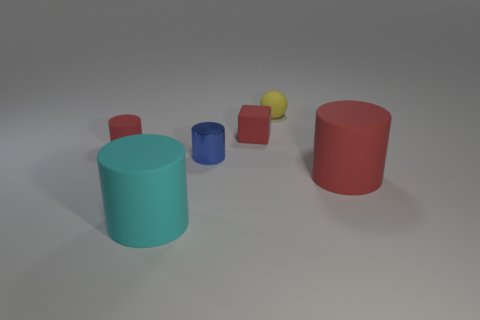Is there anything else that has the same material as the small blue cylinder?
Your answer should be compact. No. What shape is the tiny rubber object that is the same color as the small rubber cube?
Ensure brevity in your answer.  Cylinder. There is a red matte thing to the left of the large cylinder that is left of the large red rubber thing; how many big cyan rubber cylinders are behind it?
Give a very brief answer. 0. What color is the sphere that is the same size as the metallic thing?
Your answer should be compact. Yellow. There is a red object in front of the red matte cylinder that is to the left of the cube; what size is it?
Provide a short and direct response. Large. The other cylinder that is the same color as the tiny matte cylinder is what size?
Your answer should be very brief. Large. How many other objects are there of the same size as the red matte cube?
Keep it short and to the point. 3. What number of tiny brown matte cylinders are there?
Your answer should be very brief. 0. Does the cyan rubber thing have the same size as the metal cylinder?
Offer a very short reply. No. What number of other things are the same shape as the small metal thing?
Your answer should be very brief. 3. 